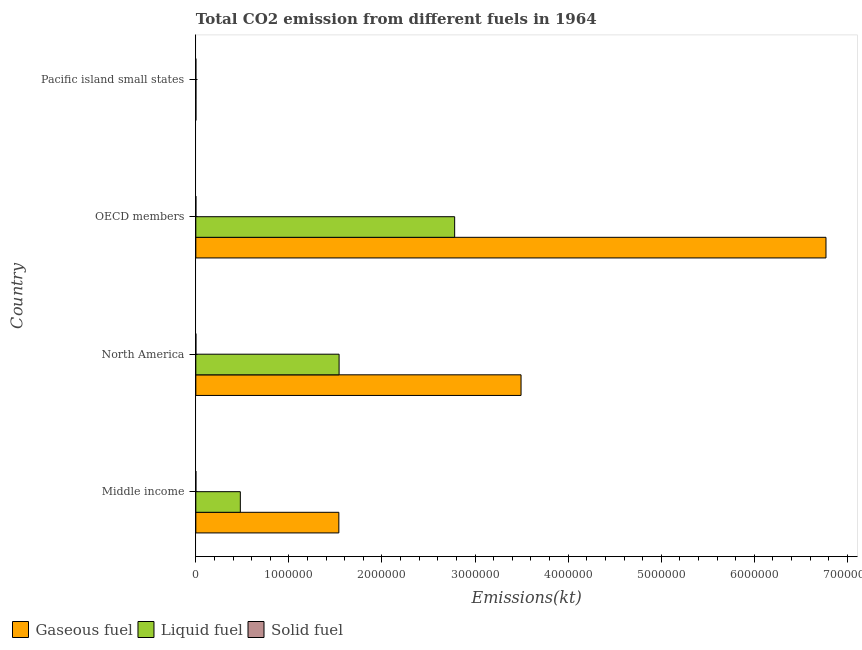How many groups of bars are there?
Keep it short and to the point. 4. What is the label of the 1st group of bars from the top?
Your answer should be very brief. Pacific island small states. What is the amount of co2 emissions from gaseous fuel in OECD members?
Keep it short and to the point. 6.77e+06. Across all countries, what is the maximum amount of co2 emissions from liquid fuel?
Keep it short and to the point. 2.78e+06. Across all countries, what is the minimum amount of co2 emissions from gaseous fuel?
Keep it short and to the point. 678.49. In which country was the amount of co2 emissions from liquid fuel maximum?
Ensure brevity in your answer.  OECD members. In which country was the amount of co2 emissions from liquid fuel minimum?
Offer a terse response. Pacific island small states. What is the total amount of co2 emissions from gaseous fuel in the graph?
Make the answer very short. 1.18e+07. What is the difference between the amount of co2 emissions from liquid fuel in North America and that in OECD members?
Keep it short and to the point. -1.24e+06. What is the difference between the amount of co2 emissions from liquid fuel in Middle income and the amount of co2 emissions from solid fuel in North America?
Keep it short and to the point. 4.78e+05. What is the average amount of co2 emissions from gaseous fuel per country?
Give a very brief answer. 2.95e+06. What is the difference between the amount of co2 emissions from gaseous fuel and amount of co2 emissions from liquid fuel in North America?
Offer a very short reply. 1.95e+06. What is the ratio of the amount of co2 emissions from liquid fuel in Middle income to that in OECD members?
Ensure brevity in your answer.  0.17. Is the difference between the amount of co2 emissions from solid fuel in OECD members and Pacific island small states greater than the difference between the amount of co2 emissions from liquid fuel in OECD members and Pacific island small states?
Provide a succinct answer. No. What is the difference between the highest and the second highest amount of co2 emissions from liquid fuel?
Your answer should be compact. 1.24e+06. What is the difference between the highest and the lowest amount of co2 emissions from solid fuel?
Offer a very short reply. 256.69. Is the sum of the amount of co2 emissions from solid fuel in OECD members and Pacific island small states greater than the maximum amount of co2 emissions from gaseous fuel across all countries?
Your answer should be compact. No. What does the 1st bar from the top in Middle income represents?
Your answer should be very brief. Solid fuel. What does the 2nd bar from the bottom in Pacific island small states represents?
Ensure brevity in your answer.  Liquid fuel. How many bars are there?
Ensure brevity in your answer.  12. Are all the bars in the graph horizontal?
Your answer should be compact. Yes. How many countries are there in the graph?
Provide a succinct answer. 4. What is the difference between two consecutive major ticks on the X-axis?
Give a very brief answer. 1.00e+06. Are the values on the major ticks of X-axis written in scientific E-notation?
Your response must be concise. No. Where does the legend appear in the graph?
Give a very brief answer. Bottom left. How many legend labels are there?
Give a very brief answer. 3. What is the title of the graph?
Your answer should be compact. Total CO2 emission from different fuels in 1964. What is the label or title of the X-axis?
Give a very brief answer. Emissions(kt). What is the Emissions(kt) of Gaseous fuel in Middle income?
Offer a very short reply. 1.54e+06. What is the Emissions(kt) in Liquid fuel in Middle income?
Make the answer very short. 4.78e+05. What is the Emissions(kt) of Solid fuel in Middle income?
Give a very brief answer. 300.69. What is the Emissions(kt) in Gaseous fuel in North America?
Provide a succinct answer. 3.49e+06. What is the Emissions(kt) in Liquid fuel in North America?
Offer a terse response. 1.54e+06. What is the Emissions(kt) of Solid fuel in North America?
Your response must be concise. 333.7. What is the Emissions(kt) in Gaseous fuel in OECD members?
Give a very brief answer. 6.77e+06. What is the Emissions(kt) of Liquid fuel in OECD members?
Provide a short and direct response. 2.78e+06. What is the Emissions(kt) of Solid fuel in OECD members?
Provide a short and direct response. 282.36. What is the Emissions(kt) of Gaseous fuel in Pacific island small states?
Your answer should be very brief. 678.49. What is the Emissions(kt) of Liquid fuel in Pacific island small states?
Your answer should be very brief. 618.21. What is the Emissions(kt) of Solid fuel in Pacific island small states?
Your answer should be compact. 77.01. Across all countries, what is the maximum Emissions(kt) in Gaseous fuel?
Provide a short and direct response. 6.77e+06. Across all countries, what is the maximum Emissions(kt) of Liquid fuel?
Your answer should be compact. 2.78e+06. Across all countries, what is the maximum Emissions(kt) of Solid fuel?
Keep it short and to the point. 333.7. Across all countries, what is the minimum Emissions(kt) in Gaseous fuel?
Offer a very short reply. 678.49. Across all countries, what is the minimum Emissions(kt) in Liquid fuel?
Keep it short and to the point. 618.21. Across all countries, what is the minimum Emissions(kt) of Solid fuel?
Offer a terse response. 77.01. What is the total Emissions(kt) in Gaseous fuel in the graph?
Provide a short and direct response. 1.18e+07. What is the total Emissions(kt) in Liquid fuel in the graph?
Provide a short and direct response. 4.80e+06. What is the total Emissions(kt) in Solid fuel in the graph?
Ensure brevity in your answer.  993.76. What is the difference between the Emissions(kt) of Gaseous fuel in Middle income and that in North America?
Offer a very short reply. -1.96e+06. What is the difference between the Emissions(kt) of Liquid fuel in Middle income and that in North America?
Your answer should be compact. -1.06e+06. What is the difference between the Emissions(kt) of Solid fuel in Middle income and that in North America?
Give a very brief answer. -33. What is the difference between the Emissions(kt) in Gaseous fuel in Middle income and that in OECD members?
Keep it short and to the point. -5.23e+06. What is the difference between the Emissions(kt) in Liquid fuel in Middle income and that in OECD members?
Your response must be concise. -2.30e+06. What is the difference between the Emissions(kt) of Solid fuel in Middle income and that in OECD members?
Ensure brevity in your answer.  18.34. What is the difference between the Emissions(kt) of Gaseous fuel in Middle income and that in Pacific island small states?
Ensure brevity in your answer.  1.54e+06. What is the difference between the Emissions(kt) in Liquid fuel in Middle income and that in Pacific island small states?
Your answer should be compact. 4.77e+05. What is the difference between the Emissions(kt) of Solid fuel in Middle income and that in Pacific island small states?
Offer a very short reply. 223.69. What is the difference between the Emissions(kt) in Gaseous fuel in North America and that in OECD members?
Your response must be concise. -3.28e+06. What is the difference between the Emissions(kt) of Liquid fuel in North America and that in OECD members?
Your answer should be very brief. -1.24e+06. What is the difference between the Emissions(kt) of Solid fuel in North America and that in OECD members?
Offer a terse response. 51.34. What is the difference between the Emissions(kt) of Gaseous fuel in North America and that in Pacific island small states?
Make the answer very short. 3.49e+06. What is the difference between the Emissions(kt) of Liquid fuel in North America and that in Pacific island small states?
Ensure brevity in your answer.  1.54e+06. What is the difference between the Emissions(kt) in Solid fuel in North America and that in Pacific island small states?
Your answer should be compact. 256.69. What is the difference between the Emissions(kt) in Gaseous fuel in OECD members and that in Pacific island small states?
Ensure brevity in your answer.  6.77e+06. What is the difference between the Emissions(kt) of Liquid fuel in OECD members and that in Pacific island small states?
Offer a terse response. 2.78e+06. What is the difference between the Emissions(kt) of Solid fuel in OECD members and that in Pacific island small states?
Ensure brevity in your answer.  205.35. What is the difference between the Emissions(kt) in Gaseous fuel in Middle income and the Emissions(kt) in Liquid fuel in North America?
Give a very brief answer. -2640.61. What is the difference between the Emissions(kt) of Gaseous fuel in Middle income and the Emissions(kt) of Solid fuel in North America?
Keep it short and to the point. 1.54e+06. What is the difference between the Emissions(kt) in Liquid fuel in Middle income and the Emissions(kt) in Solid fuel in North America?
Provide a short and direct response. 4.78e+05. What is the difference between the Emissions(kt) of Gaseous fuel in Middle income and the Emissions(kt) of Liquid fuel in OECD members?
Provide a succinct answer. -1.24e+06. What is the difference between the Emissions(kt) in Gaseous fuel in Middle income and the Emissions(kt) in Solid fuel in OECD members?
Your response must be concise. 1.54e+06. What is the difference between the Emissions(kt) in Liquid fuel in Middle income and the Emissions(kt) in Solid fuel in OECD members?
Provide a short and direct response. 4.78e+05. What is the difference between the Emissions(kt) in Gaseous fuel in Middle income and the Emissions(kt) in Liquid fuel in Pacific island small states?
Your answer should be very brief. 1.54e+06. What is the difference between the Emissions(kt) of Gaseous fuel in Middle income and the Emissions(kt) of Solid fuel in Pacific island small states?
Offer a terse response. 1.54e+06. What is the difference between the Emissions(kt) of Liquid fuel in Middle income and the Emissions(kt) of Solid fuel in Pacific island small states?
Ensure brevity in your answer.  4.78e+05. What is the difference between the Emissions(kt) of Gaseous fuel in North America and the Emissions(kt) of Liquid fuel in OECD members?
Your answer should be compact. 7.13e+05. What is the difference between the Emissions(kt) in Gaseous fuel in North America and the Emissions(kt) in Solid fuel in OECD members?
Keep it short and to the point. 3.49e+06. What is the difference between the Emissions(kt) of Liquid fuel in North America and the Emissions(kt) of Solid fuel in OECD members?
Provide a short and direct response. 1.54e+06. What is the difference between the Emissions(kt) of Gaseous fuel in North America and the Emissions(kt) of Liquid fuel in Pacific island small states?
Give a very brief answer. 3.49e+06. What is the difference between the Emissions(kt) of Gaseous fuel in North America and the Emissions(kt) of Solid fuel in Pacific island small states?
Offer a very short reply. 3.49e+06. What is the difference between the Emissions(kt) in Liquid fuel in North America and the Emissions(kt) in Solid fuel in Pacific island small states?
Your answer should be very brief. 1.54e+06. What is the difference between the Emissions(kt) of Gaseous fuel in OECD members and the Emissions(kt) of Liquid fuel in Pacific island small states?
Keep it short and to the point. 6.77e+06. What is the difference between the Emissions(kt) of Gaseous fuel in OECD members and the Emissions(kt) of Solid fuel in Pacific island small states?
Ensure brevity in your answer.  6.77e+06. What is the difference between the Emissions(kt) in Liquid fuel in OECD members and the Emissions(kt) in Solid fuel in Pacific island small states?
Offer a very short reply. 2.78e+06. What is the average Emissions(kt) in Gaseous fuel per country?
Give a very brief answer. 2.95e+06. What is the average Emissions(kt) in Liquid fuel per country?
Offer a terse response. 1.20e+06. What is the average Emissions(kt) of Solid fuel per country?
Your answer should be compact. 248.44. What is the difference between the Emissions(kt) of Gaseous fuel and Emissions(kt) of Liquid fuel in Middle income?
Offer a very short reply. 1.06e+06. What is the difference between the Emissions(kt) of Gaseous fuel and Emissions(kt) of Solid fuel in Middle income?
Keep it short and to the point. 1.54e+06. What is the difference between the Emissions(kt) of Liquid fuel and Emissions(kt) of Solid fuel in Middle income?
Keep it short and to the point. 4.78e+05. What is the difference between the Emissions(kt) of Gaseous fuel and Emissions(kt) of Liquid fuel in North America?
Provide a succinct answer. 1.95e+06. What is the difference between the Emissions(kt) in Gaseous fuel and Emissions(kt) in Solid fuel in North America?
Provide a succinct answer. 3.49e+06. What is the difference between the Emissions(kt) of Liquid fuel and Emissions(kt) of Solid fuel in North America?
Offer a very short reply. 1.54e+06. What is the difference between the Emissions(kt) in Gaseous fuel and Emissions(kt) in Liquid fuel in OECD members?
Your answer should be compact. 3.99e+06. What is the difference between the Emissions(kt) of Gaseous fuel and Emissions(kt) of Solid fuel in OECD members?
Offer a very short reply. 6.77e+06. What is the difference between the Emissions(kt) of Liquid fuel and Emissions(kt) of Solid fuel in OECD members?
Provide a succinct answer. 2.78e+06. What is the difference between the Emissions(kt) of Gaseous fuel and Emissions(kt) of Liquid fuel in Pacific island small states?
Keep it short and to the point. 60.28. What is the difference between the Emissions(kt) in Gaseous fuel and Emissions(kt) in Solid fuel in Pacific island small states?
Give a very brief answer. 601.48. What is the difference between the Emissions(kt) of Liquid fuel and Emissions(kt) of Solid fuel in Pacific island small states?
Keep it short and to the point. 541.2. What is the ratio of the Emissions(kt) in Gaseous fuel in Middle income to that in North America?
Ensure brevity in your answer.  0.44. What is the ratio of the Emissions(kt) of Liquid fuel in Middle income to that in North America?
Keep it short and to the point. 0.31. What is the ratio of the Emissions(kt) of Solid fuel in Middle income to that in North America?
Give a very brief answer. 0.9. What is the ratio of the Emissions(kt) in Gaseous fuel in Middle income to that in OECD members?
Ensure brevity in your answer.  0.23. What is the ratio of the Emissions(kt) in Liquid fuel in Middle income to that in OECD members?
Your answer should be very brief. 0.17. What is the ratio of the Emissions(kt) of Solid fuel in Middle income to that in OECD members?
Your answer should be compact. 1.06. What is the ratio of the Emissions(kt) in Gaseous fuel in Middle income to that in Pacific island small states?
Make the answer very short. 2264.52. What is the ratio of the Emissions(kt) in Liquid fuel in Middle income to that in Pacific island small states?
Keep it short and to the point. 773.38. What is the ratio of the Emissions(kt) in Solid fuel in Middle income to that in Pacific island small states?
Keep it short and to the point. 3.9. What is the ratio of the Emissions(kt) in Gaseous fuel in North America to that in OECD members?
Keep it short and to the point. 0.52. What is the ratio of the Emissions(kt) of Liquid fuel in North America to that in OECD members?
Give a very brief answer. 0.55. What is the ratio of the Emissions(kt) of Solid fuel in North America to that in OECD members?
Your response must be concise. 1.18. What is the ratio of the Emissions(kt) of Gaseous fuel in North America to that in Pacific island small states?
Give a very brief answer. 5149.66. What is the ratio of the Emissions(kt) of Liquid fuel in North America to that in Pacific island small states?
Provide a succinct answer. 2489.6. What is the ratio of the Emissions(kt) of Solid fuel in North America to that in Pacific island small states?
Provide a succinct answer. 4.33. What is the ratio of the Emissions(kt) in Gaseous fuel in OECD members to that in Pacific island small states?
Provide a succinct answer. 9978.15. What is the ratio of the Emissions(kt) of Liquid fuel in OECD members to that in Pacific island small states?
Offer a terse response. 4498.1. What is the ratio of the Emissions(kt) in Solid fuel in OECD members to that in Pacific island small states?
Your response must be concise. 3.67. What is the difference between the highest and the second highest Emissions(kt) in Gaseous fuel?
Make the answer very short. 3.28e+06. What is the difference between the highest and the second highest Emissions(kt) of Liquid fuel?
Offer a terse response. 1.24e+06. What is the difference between the highest and the second highest Emissions(kt) of Solid fuel?
Offer a very short reply. 33. What is the difference between the highest and the lowest Emissions(kt) in Gaseous fuel?
Give a very brief answer. 6.77e+06. What is the difference between the highest and the lowest Emissions(kt) in Liquid fuel?
Offer a very short reply. 2.78e+06. What is the difference between the highest and the lowest Emissions(kt) in Solid fuel?
Make the answer very short. 256.69. 